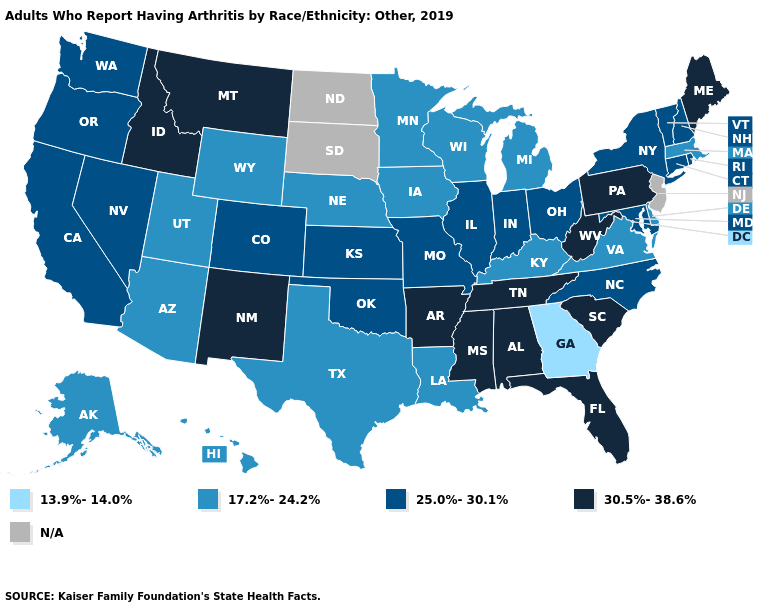Which states have the lowest value in the USA?
Give a very brief answer. Georgia. What is the value of Hawaii?
Answer briefly. 17.2%-24.2%. Name the states that have a value in the range 30.5%-38.6%?
Keep it brief. Alabama, Arkansas, Florida, Idaho, Maine, Mississippi, Montana, New Mexico, Pennsylvania, South Carolina, Tennessee, West Virginia. Does the first symbol in the legend represent the smallest category?
Concise answer only. Yes. Name the states that have a value in the range 17.2%-24.2%?
Short answer required. Alaska, Arizona, Delaware, Hawaii, Iowa, Kentucky, Louisiana, Massachusetts, Michigan, Minnesota, Nebraska, Texas, Utah, Virginia, Wisconsin, Wyoming. Does Massachusetts have the lowest value in the Northeast?
Be succinct. Yes. Name the states that have a value in the range 25.0%-30.1%?
Answer briefly. California, Colorado, Connecticut, Illinois, Indiana, Kansas, Maryland, Missouri, Nevada, New Hampshire, New York, North Carolina, Ohio, Oklahoma, Oregon, Rhode Island, Vermont, Washington. Does Rhode Island have the highest value in the Northeast?
Be succinct. No. Which states have the lowest value in the USA?
Keep it brief. Georgia. Which states have the lowest value in the USA?
Write a very short answer. Georgia. Does the first symbol in the legend represent the smallest category?
Be succinct. Yes. What is the value of Alabama?
Give a very brief answer. 30.5%-38.6%. Name the states that have a value in the range N/A?
Give a very brief answer. New Jersey, North Dakota, South Dakota. 